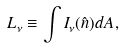<formula> <loc_0><loc_0><loc_500><loc_500>L _ { \nu } \equiv \int I _ { \nu } ( \hat { n } ) d A ,</formula> 